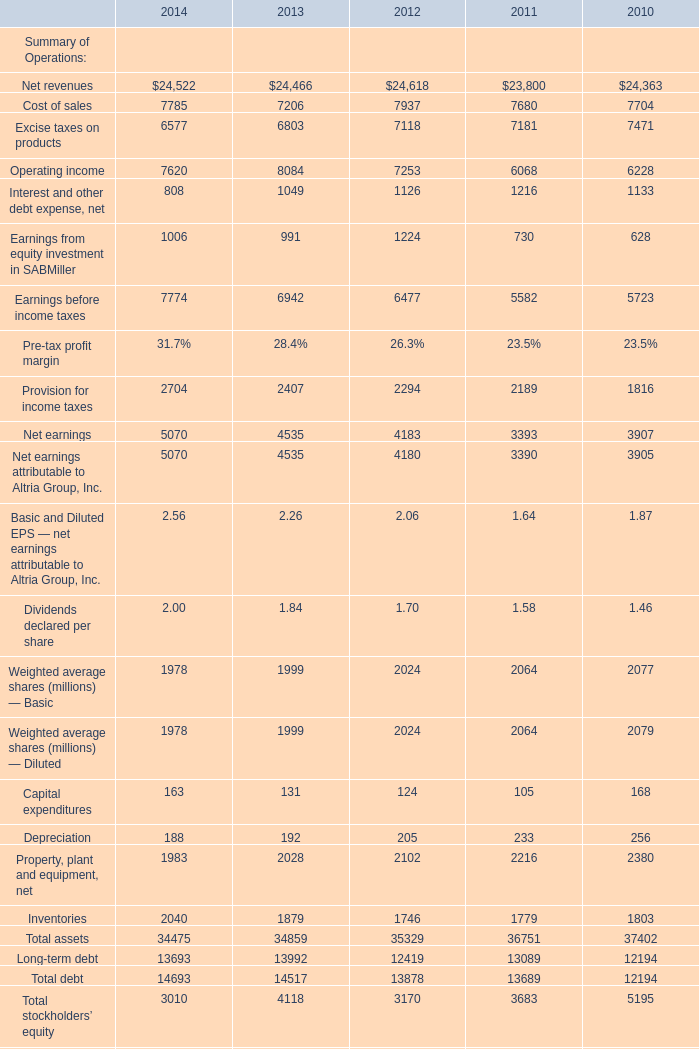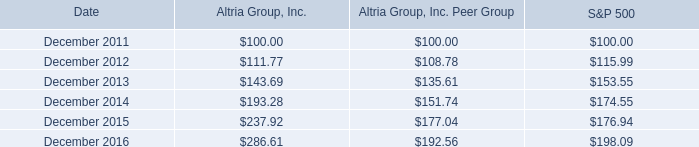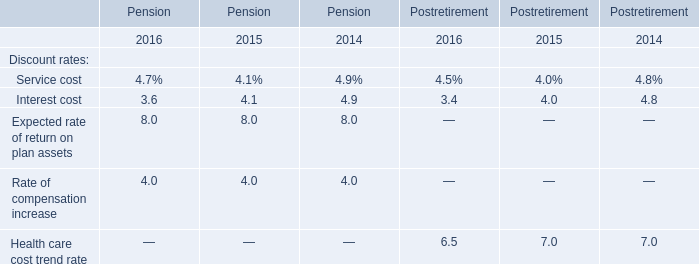Does Net revenues keeps increasing each year between 2014 and 2013? 
Answer: Yes. 